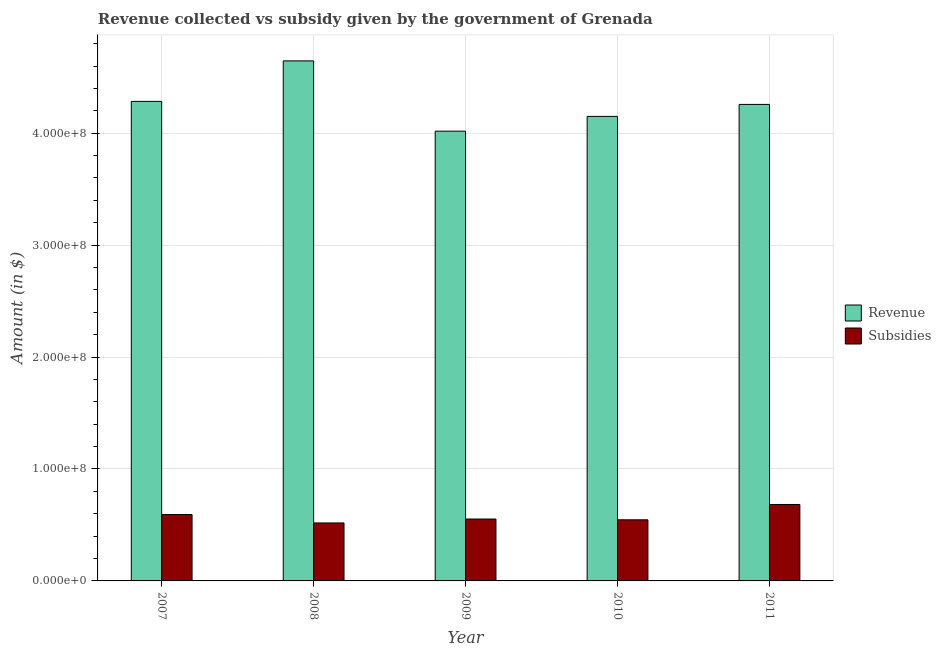How many different coloured bars are there?
Keep it short and to the point. 2. How many groups of bars are there?
Provide a short and direct response. 5. Are the number of bars per tick equal to the number of legend labels?
Provide a succinct answer. Yes. Are the number of bars on each tick of the X-axis equal?
Your answer should be very brief. Yes. How many bars are there on the 4th tick from the left?
Give a very brief answer. 2. What is the label of the 5th group of bars from the left?
Your response must be concise. 2011. What is the amount of subsidies given in 2011?
Keep it short and to the point. 6.83e+07. Across all years, what is the maximum amount of revenue collected?
Give a very brief answer. 4.65e+08. Across all years, what is the minimum amount of subsidies given?
Offer a terse response. 5.18e+07. In which year was the amount of subsidies given minimum?
Provide a short and direct response. 2008. What is the total amount of revenue collected in the graph?
Your answer should be very brief. 2.14e+09. What is the difference between the amount of revenue collected in 2007 and that in 2009?
Keep it short and to the point. 2.66e+07. What is the difference between the amount of subsidies given in 2008 and the amount of revenue collected in 2010?
Keep it short and to the point. -2.80e+06. What is the average amount of subsidies given per year?
Make the answer very short. 5.79e+07. What is the ratio of the amount of subsidies given in 2008 to that in 2009?
Your response must be concise. 0.94. Is the amount of subsidies given in 2010 less than that in 2011?
Provide a short and direct response. Yes. Is the difference between the amount of subsidies given in 2009 and 2011 greater than the difference between the amount of revenue collected in 2009 and 2011?
Make the answer very short. No. What is the difference between the highest and the second highest amount of revenue collected?
Your answer should be compact. 3.62e+07. What is the difference between the highest and the lowest amount of revenue collected?
Provide a succinct answer. 6.28e+07. In how many years, is the amount of subsidies given greater than the average amount of subsidies given taken over all years?
Your answer should be compact. 2. What does the 1st bar from the left in 2008 represents?
Offer a very short reply. Revenue. What does the 2nd bar from the right in 2007 represents?
Keep it short and to the point. Revenue. How many bars are there?
Your response must be concise. 10. How many years are there in the graph?
Your answer should be very brief. 5. Does the graph contain any zero values?
Offer a very short reply. No. Where does the legend appear in the graph?
Ensure brevity in your answer.  Center right. How many legend labels are there?
Make the answer very short. 2. What is the title of the graph?
Your response must be concise. Revenue collected vs subsidy given by the government of Grenada. Does "Highest 20% of population" appear as one of the legend labels in the graph?
Provide a succinct answer. No. What is the label or title of the X-axis?
Give a very brief answer. Year. What is the label or title of the Y-axis?
Provide a short and direct response. Amount (in $). What is the Amount (in $) of Revenue in 2007?
Make the answer very short. 4.28e+08. What is the Amount (in $) in Subsidies in 2007?
Your answer should be compact. 5.93e+07. What is the Amount (in $) in Revenue in 2008?
Make the answer very short. 4.65e+08. What is the Amount (in $) of Subsidies in 2008?
Offer a very short reply. 5.18e+07. What is the Amount (in $) in Revenue in 2009?
Your answer should be very brief. 4.02e+08. What is the Amount (in $) of Subsidies in 2009?
Provide a short and direct response. 5.53e+07. What is the Amount (in $) in Revenue in 2010?
Ensure brevity in your answer.  4.15e+08. What is the Amount (in $) in Subsidies in 2010?
Offer a terse response. 5.46e+07. What is the Amount (in $) in Revenue in 2011?
Keep it short and to the point. 4.26e+08. What is the Amount (in $) in Subsidies in 2011?
Your answer should be compact. 6.83e+07. Across all years, what is the maximum Amount (in $) in Revenue?
Your response must be concise. 4.65e+08. Across all years, what is the maximum Amount (in $) in Subsidies?
Offer a very short reply. 6.83e+07. Across all years, what is the minimum Amount (in $) of Revenue?
Offer a very short reply. 4.02e+08. Across all years, what is the minimum Amount (in $) in Subsidies?
Keep it short and to the point. 5.18e+07. What is the total Amount (in $) in Revenue in the graph?
Your response must be concise. 2.14e+09. What is the total Amount (in $) in Subsidies in the graph?
Your answer should be compact. 2.89e+08. What is the difference between the Amount (in $) of Revenue in 2007 and that in 2008?
Your answer should be compact. -3.62e+07. What is the difference between the Amount (in $) of Subsidies in 2007 and that in 2008?
Give a very brief answer. 7.50e+06. What is the difference between the Amount (in $) in Revenue in 2007 and that in 2009?
Provide a short and direct response. 2.66e+07. What is the difference between the Amount (in $) of Subsidies in 2007 and that in 2009?
Ensure brevity in your answer.  4.00e+06. What is the difference between the Amount (in $) of Revenue in 2007 and that in 2010?
Offer a terse response. 1.34e+07. What is the difference between the Amount (in $) in Subsidies in 2007 and that in 2010?
Keep it short and to the point. 4.70e+06. What is the difference between the Amount (in $) in Revenue in 2007 and that in 2011?
Make the answer very short. 2.70e+06. What is the difference between the Amount (in $) of Subsidies in 2007 and that in 2011?
Give a very brief answer. -9.00e+06. What is the difference between the Amount (in $) of Revenue in 2008 and that in 2009?
Keep it short and to the point. 6.28e+07. What is the difference between the Amount (in $) of Subsidies in 2008 and that in 2009?
Offer a terse response. -3.50e+06. What is the difference between the Amount (in $) in Revenue in 2008 and that in 2010?
Your response must be concise. 4.96e+07. What is the difference between the Amount (in $) in Subsidies in 2008 and that in 2010?
Provide a succinct answer. -2.80e+06. What is the difference between the Amount (in $) in Revenue in 2008 and that in 2011?
Provide a short and direct response. 3.89e+07. What is the difference between the Amount (in $) in Subsidies in 2008 and that in 2011?
Your answer should be compact. -1.65e+07. What is the difference between the Amount (in $) of Revenue in 2009 and that in 2010?
Keep it short and to the point. -1.32e+07. What is the difference between the Amount (in $) of Revenue in 2009 and that in 2011?
Your answer should be compact. -2.39e+07. What is the difference between the Amount (in $) of Subsidies in 2009 and that in 2011?
Provide a succinct answer. -1.30e+07. What is the difference between the Amount (in $) of Revenue in 2010 and that in 2011?
Your answer should be compact. -1.07e+07. What is the difference between the Amount (in $) in Subsidies in 2010 and that in 2011?
Your response must be concise. -1.37e+07. What is the difference between the Amount (in $) of Revenue in 2007 and the Amount (in $) of Subsidies in 2008?
Offer a terse response. 3.77e+08. What is the difference between the Amount (in $) in Revenue in 2007 and the Amount (in $) in Subsidies in 2009?
Make the answer very short. 3.73e+08. What is the difference between the Amount (in $) in Revenue in 2007 and the Amount (in $) in Subsidies in 2010?
Your answer should be compact. 3.74e+08. What is the difference between the Amount (in $) in Revenue in 2007 and the Amount (in $) in Subsidies in 2011?
Make the answer very short. 3.60e+08. What is the difference between the Amount (in $) in Revenue in 2008 and the Amount (in $) in Subsidies in 2009?
Provide a succinct answer. 4.09e+08. What is the difference between the Amount (in $) of Revenue in 2008 and the Amount (in $) of Subsidies in 2010?
Your answer should be compact. 4.10e+08. What is the difference between the Amount (in $) of Revenue in 2008 and the Amount (in $) of Subsidies in 2011?
Your answer should be very brief. 3.96e+08. What is the difference between the Amount (in $) of Revenue in 2009 and the Amount (in $) of Subsidies in 2010?
Make the answer very short. 3.47e+08. What is the difference between the Amount (in $) in Revenue in 2009 and the Amount (in $) in Subsidies in 2011?
Keep it short and to the point. 3.34e+08. What is the difference between the Amount (in $) of Revenue in 2010 and the Amount (in $) of Subsidies in 2011?
Provide a short and direct response. 3.47e+08. What is the average Amount (in $) of Revenue per year?
Your response must be concise. 4.27e+08. What is the average Amount (in $) in Subsidies per year?
Provide a succinct answer. 5.79e+07. In the year 2007, what is the difference between the Amount (in $) of Revenue and Amount (in $) of Subsidies?
Keep it short and to the point. 3.69e+08. In the year 2008, what is the difference between the Amount (in $) in Revenue and Amount (in $) in Subsidies?
Your answer should be very brief. 4.13e+08. In the year 2009, what is the difference between the Amount (in $) in Revenue and Amount (in $) in Subsidies?
Your response must be concise. 3.46e+08. In the year 2010, what is the difference between the Amount (in $) in Revenue and Amount (in $) in Subsidies?
Offer a very short reply. 3.60e+08. In the year 2011, what is the difference between the Amount (in $) in Revenue and Amount (in $) in Subsidies?
Your response must be concise. 3.57e+08. What is the ratio of the Amount (in $) in Revenue in 2007 to that in 2008?
Offer a terse response. 0.92. What is the ratio of the Amount (in $) of Subsidies in 2007 to that in 2008?
Offer a very short reply. 1.14. What is the ratio of the Amount (in $) in Revenue in 2007 to that in 2009?
Your response must be concise. 1.07. What is the ratio of the Amount (in $) of Subsidies in 2007 to that in 2009?
Keep it short and to the point. 1.07. What is the ratio of the Amount (in $) of Revenue in 2007 to that in 2010?
Your answer should be compact. 1.03. What is the ratio of the Amount (in $) in Subsidies in 2007 to that in 2010?
Offer a very short reply. 1.09. What is the ratio of the Amount (in $) in Revenue in 2007 to that in 2011?
Make the answer very short. 1.01. What is the ratio of the Amount (in $) of Subsidies in 2007 to that in 2011?
Give a very brief answer. 0.87. What is the ratio of the Amount (in $) in Revenue in 2008 to that in 2009?
Offer a terse response. 1.16. What is the ratio of the Amount (in $) in Subsidies in 2008 to that in 2009?
Offer a very short reply. 0.94. What is the ratio of the Amount (in $) in Revenue in 2008 to that in 2010?
Keep it short and to the point. 1.12. What is the ratio of the Amount (in $) of Subsidies in 2008 to that in 2010?
Give a very brief answer. 0.95. What is the ratio of the Amount (in $) of Revenue in 2008 to that in 2011?
Offer a very short reply. 1.09. What is the ratio of the Amount (in $) of Subsidies in 2008 to that in 2011?
Provide a succinct answer. 0.76. What is the ratio of the Amount (in $) of Revenue in 2009 to that in 2010?
Your answer should be compact. 0.97. What is the ratio of the Amount (in $) in Subsidies in 2009 to that in 2010?
Your answer should be very brief. 1.01. What is the ratio of the Amount (in $) of Revenue in 2009 to that in 2011?
Offer a very short reply. 0.94. What is the ratio of the Amount (in $) in Subsidies in 2009 to that in 2011?
Your answer should be compact. 0.81. What is the ratio of the Amount (in $) of Revenue in 2010 to that in 2011?
Make the answer very short. 0.97. What is the ratio of the Amount (in $) in Subsidies in 2010 to that in 2011?
Keep it short and to the point. 0.8. What is the difference between the highest and the second highest Amount (in $) of Revenue?
Offer a terse response. 3.62e+07. What is the difference between the highest and the second highest Amount (in $) of Subsidies?
Your answer should be very brief. 9.00e+06. What is the difference between the highest and the lowest Amount (in $) in Revenue?
Offer a very short reply. 6.28e+07. What is the difference between the highest and the lowest Amount (in $) in Subsidies?
Give a very brief answer. 1.65e+07. 